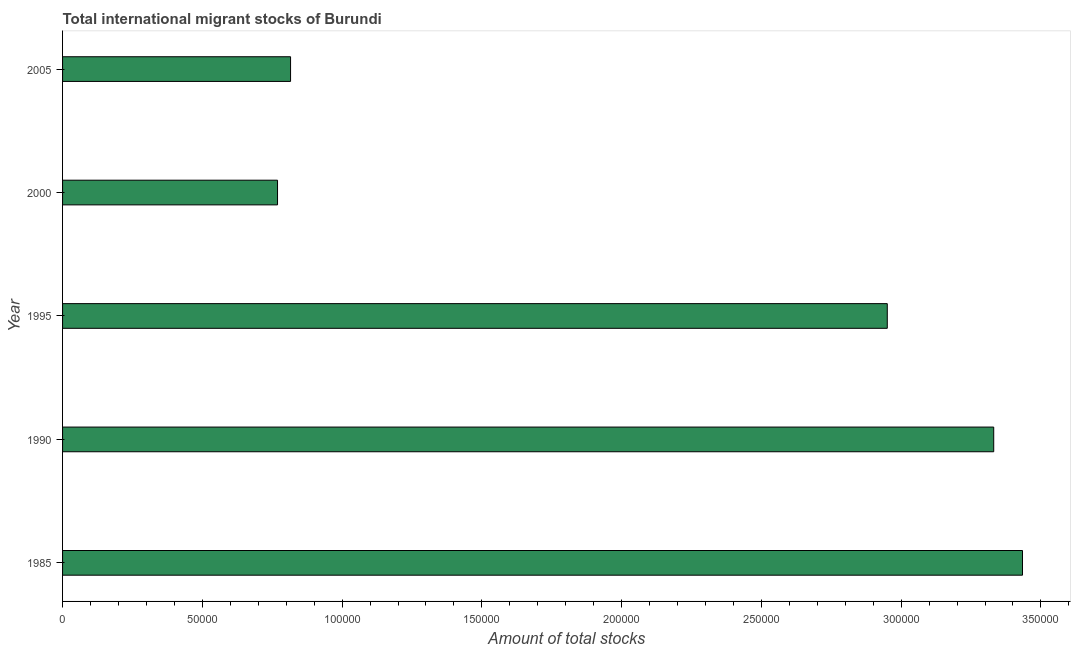What is the title of the graph?
Give a very brief answer. Total international migrant stocks of Burundi. What is the label or title of the X-axis?
Make the answer very short. Amount of total stocks. What is the total number of international migrant stock in 2000?
Offer a very short reply. 7.69e+04. Across all years, what is the maximum total number of international migrant stock?
Your answer should be very brief. 3.43e+05. Across all years, what is the minimum total number of international migrant stock?
Offer a terse response. 7.69e+04. In which year was the total number of international migrant stock maximum?
Provide a succinct answer. 1985. In which year was the total number of international migrant stock minimum?
Provide a succinct answer. 2000. What is the sum of the total number of international migrant stock?
Ensure brevity in your answer.  1.13e+06. What is the difference between the total number of international migrant stock in 1985 and 1995?
Your answer should be compact. 4.84e+04. What is the average total number of international migrant stock per year?
Give a very brief answer. 2.26e+05. What is the median total number of international migrant stock?
Offer a terse response. 2.95e+05. What is the ratio of the total number of international migrant stock in 1990 to that in 2000?
Your response must be concise. 4.33. Is the total number of international migrant stock in 2000 less than that in 2005?
Offer a very short reply. Yes. Is the difference between the total number of international migrant stock in 1985 and 1990 greater than the difference between any two years?
Provide a short and direct response. No. What is the difference between the highest and the second highest total number of international migrant stock?
Make the answer very short. 1.03e+04. What is the difference between the highest and the lowest total number of international migrant stock?
Your response must be concise. 2.67e+05. How many bars are there?
Make the answer very short. 5. Are all the bars in the graph horizontal?
Keep it short and to the point. Yes. How many years are there in the graph?
Provide a short and direct response. 5. Are the values on the major ticks of X-axis written in scientific E-notation?
Provide a succinct answer. No. What is the Amount of total stocks in 1985?
Your response must be concise. 3.43e+05. What is the Amount of total stocks of 1990?
Your answer should be compact. 3.33e+05. What is the Amount of total stocks in 1995?
Offer a very short reply. 2.95e+05. What is the Amount of total stocks of 2000?
Offer a very short reply. 7.69e+04. What is the Amount of total stocks of 2005?
Offer a very short reply. 8.16e+04. What is the difference between the Amount of total stocks in 1985 and 1990?
Ensure brevity in your answer.  1.03e+04. What is the difference between the Amount of total stocks in 1985 and 1995?
Offer a very short reply. 4.84e+04. What is the difference between the Amount of total stocks in 1985 and 2000?
Your answer should be compact. 2.67e+05. What is the difference between the Amount of total stocks in 1985 and 2005?
Ensure brevity in your answer.  2.62e+05. What is the difference between the Amount of total stocks in 1990 and 1995?
Give a very brief answer. 3.81e+04. What is the difference between the Amount of total stocks in 1990 and 2000?
Your response must be concise. 2.56e+05. What is the difference between the Amount of total stocks in 1990 and 2005?
Offer a terse response. 2.52e+05. What is the difference between the Amount of total stocks in 1995 and 2000?
Your answer should be very brief. 2.18e+05. What is the difference between the Amount of total stocks in 1995 and 2005?
Offer a terse response. 2.13e+05. What is the difference between the Amount of total stocks in 2000 and 2005?
Provide a short and direct response. -4663. What is the ratio of the Amount of total stocks in 1985 to that in 1990?
Offer a very short reply. 1.03. What is the ratio of the Amount of total stocks in 1985 to that in 1995?
Your response must be concise. 1.16. What is the ratio of the Amount of total stocks in 1985 to that in 2000?
Your answer should be very brief. 4.46. What is the ratio of the Amount of total stocks in 1985 to that in 2005?
Your answer should be very brief. 4.21. What is the ratio of the Amount of total stocks in 1990 to that in 1995?
Your response must be concise. 1.13. What is the ratio of the Amount of total stocks in 1990 to that in 2000?
Provide a succinct answer. 4.33. What is the ratio of the Amount of total stocks in 1990 to that in 2005?
Make the answer very short. 4.08. What is the ratio of the Amount of total stocks in 1995 to that in 2000?
Offer a terse response. 3.84. What is the ratio of the Amount of total stocks in 1995 to that in 2005?
Your answer should be very brief. 3.62. What is the ratio of the Amount of total stocks in 2000 to that in 2005?
Your response must be concise. 0.94. 